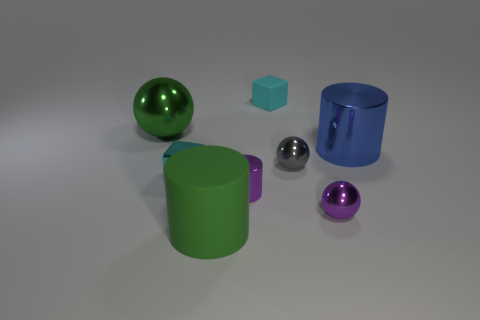How many shiny objects are both in front of the small gray sphere and to the right of the tiny gray object?
Your answer should be very brief. 1. Is there any other thing that has the same shape as the green metal thing?
Your answer should be very brief. Yes. What is the size of the thing to the right of the purple metallic sphere?
Keep it short and to the point. Large. How many other things are the same color as the large matte object?
Provide a succinct answer. 1. What material is the tiny cyan cube in front of the green sphere behind the blue cylinder made of?
Your answer should be very brief. Metal. Is the color of the tiny block on the left side of the green cylinder the same as the matte cube?
Your answer should be compact. Yes. Are there any other things that are made of the same material as the large blue object?
Offer a very short reply. Yes. How many small cyan things have the same shape as the green rubber thing?
Provide a short and direct response. 0. What is the size of the blue object that is made of the same material as the green ball?
Offer a terse response. Large. There is a block behind the large cylinder to the right of the matte cylinder; are there any green shiny balls in front of it?
Offer a terse response. Yes. 